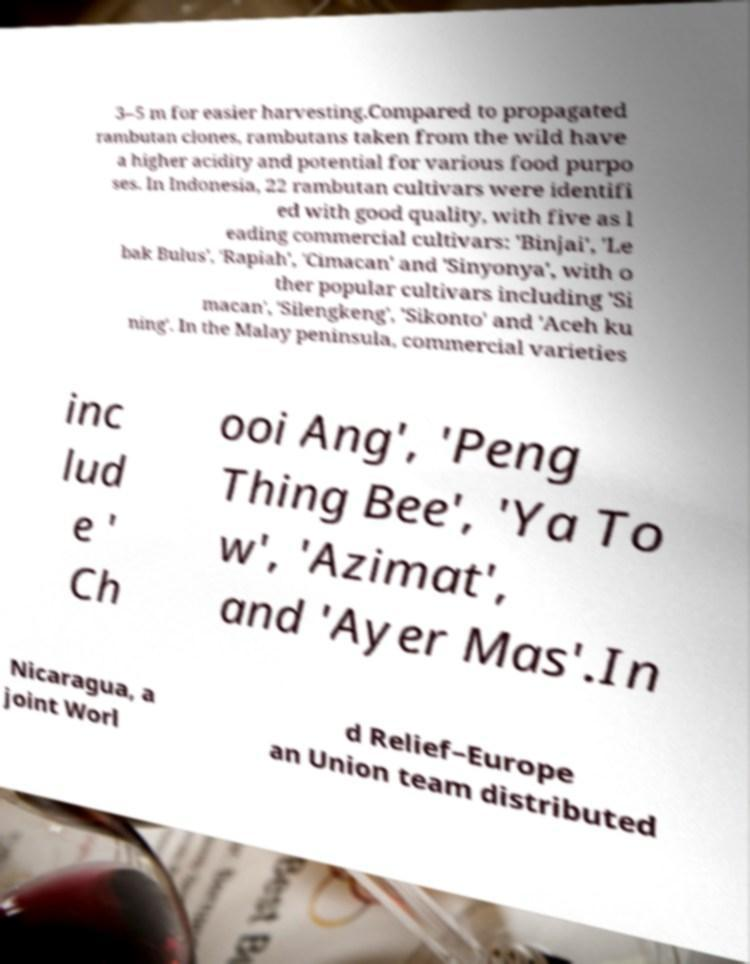Please read and relay the text visible in this image. What does it say? 3–5 m for easier harvesting.Compared to propagated rambutan clones, rambutans taken from the wild have a higher acidity and potential for various food purpo ses. In Indonesia, 22 rambutan cultivars were identifi ed with good quality, with five as l eading commercial cultivars: 'Binjai', 'Le bak Bulus', 'Rapiah', 'Cimacan' and 'Sinyonya', with o ther popular cultivars including 'Si macan', 'Silengkeng', 'Sikonto' and 'Aceh ku ning'. In the Malay peninsula, commercial varieties inc lud e ' Ch ooi Ang', 'Peng Thing Bee', 'Ya To w', 'Azimat', and 'Ayer Mas'.In Nicaragua, a joint Worl d Relief–Europe an Union team distributed 